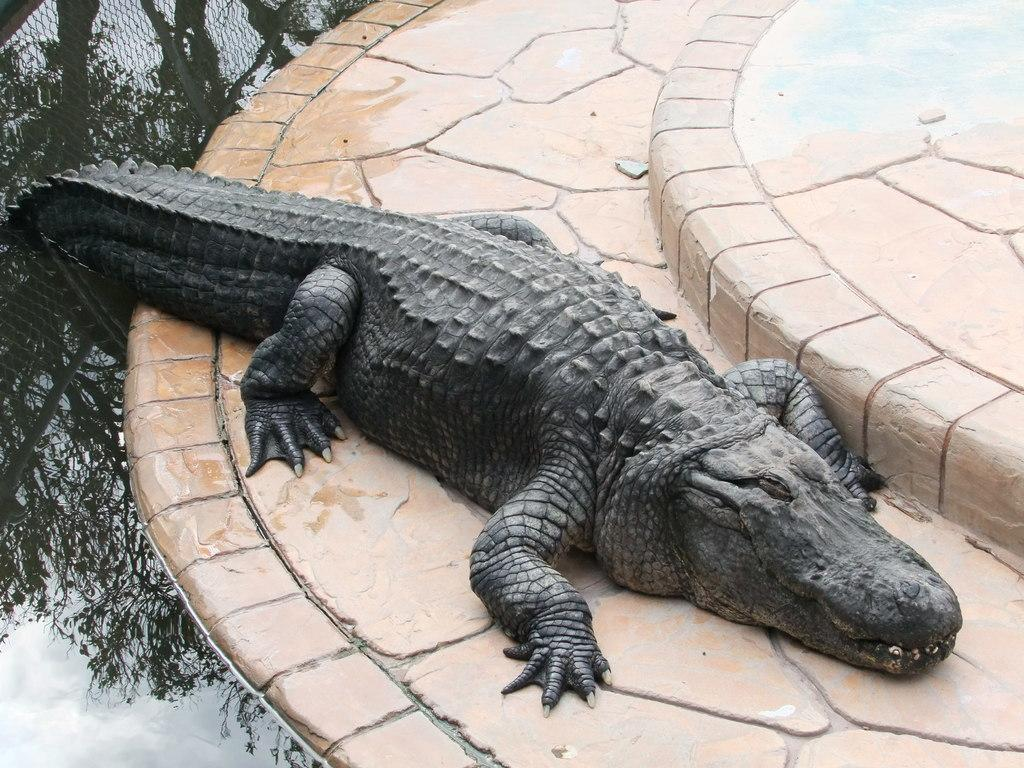What animal is present in the image? There is a crocodile in the image. What can be seen on the left side of the image? There is a pond on the left side of the image. What type of eggnog is being served in the image? There is no eggnog present in the image, as it features a crocodile and a pond. 